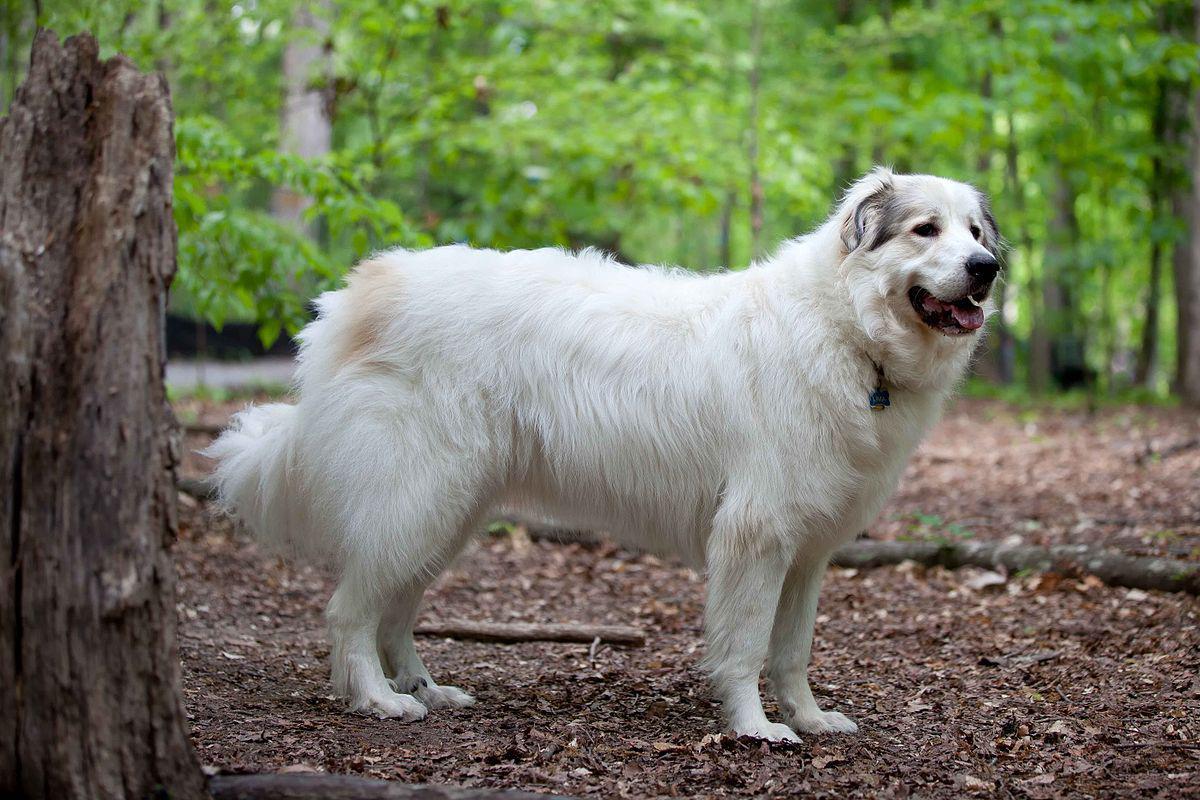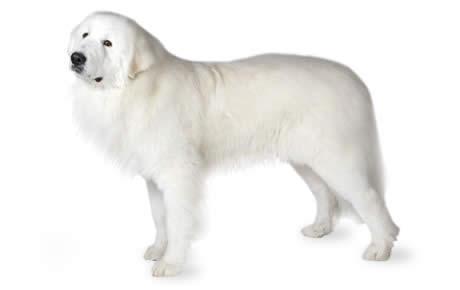The first image is the image on the left, the second image is the image on the right. Examine the images to the left and right. Is the description "The right image shows a white dog in profile with a nature backdrop." accurate? Answer yes or no. No. 